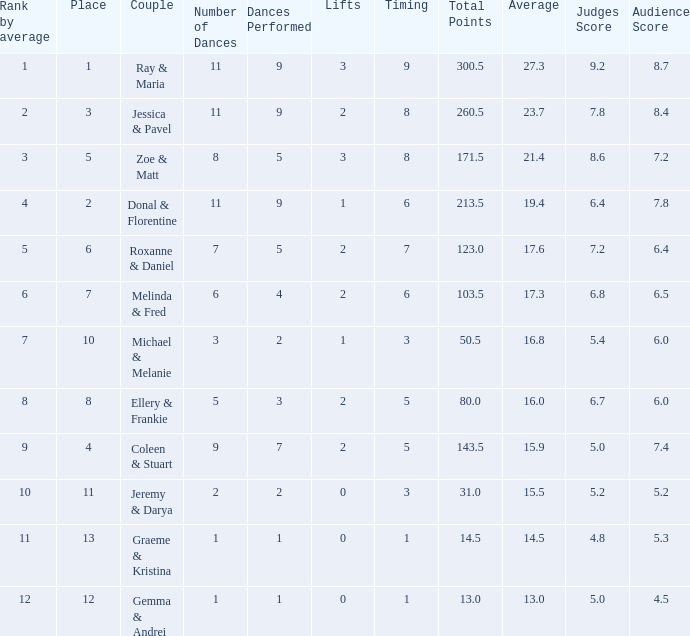What is the couples name where the average is 15.9? Coleen & Stuart. 